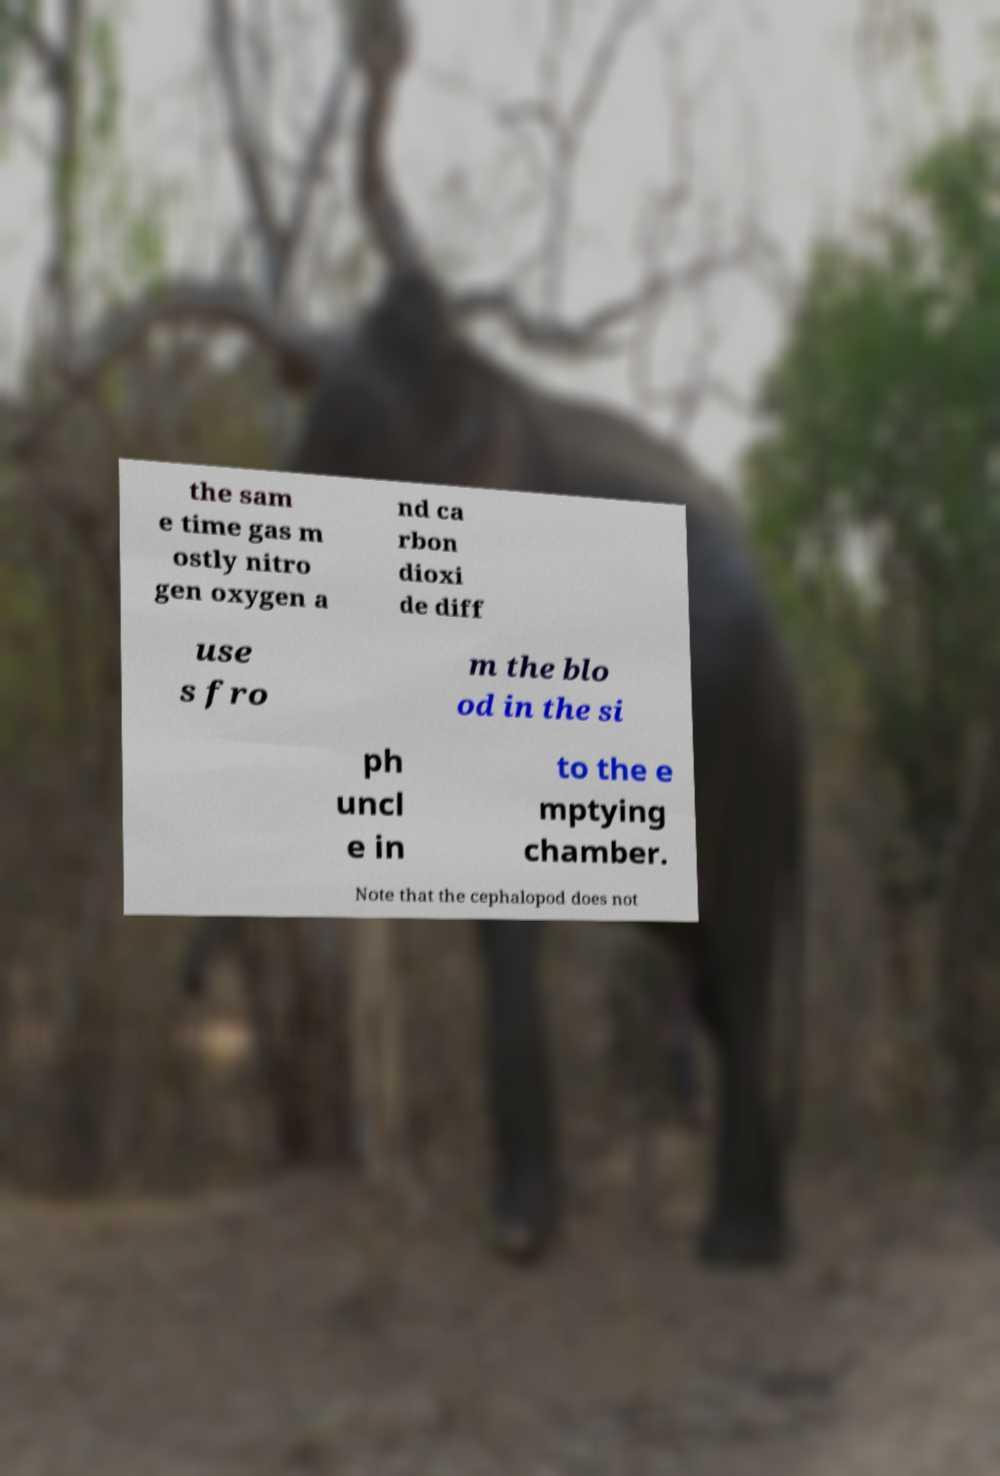Please identify and transcribe the text found in this image. the sam e time gas m ostly nitro gen oxygen a nd ca rbon dioxi de diff use s fro m the blo od in the si ph uncl e in to the e mptying chamber. Note that the cephalopod does not 